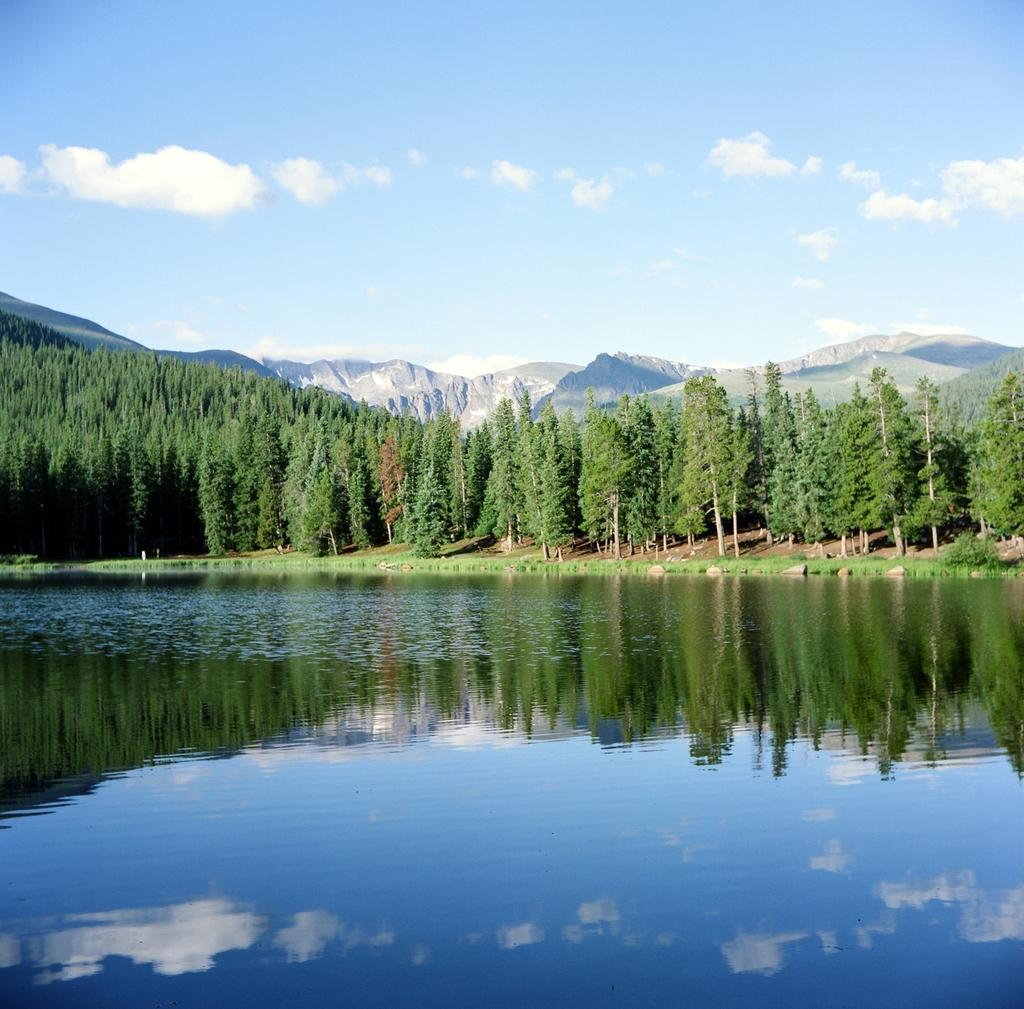What is visible in the image? Water, ground, green and brown trees, mountains, and the sky are visible in the image. Can you describe the trees in the image? The trees in the image are green and brown. What is the background of the image? The background of the image includes mountains and the sky. Are there any giants visible in the image? No, there are no giants present in the image. What type of quill is being used to write on the water in the image? There is no quill or writing activity visible in the image; it features natural elements such as water, trees, and mountains. 